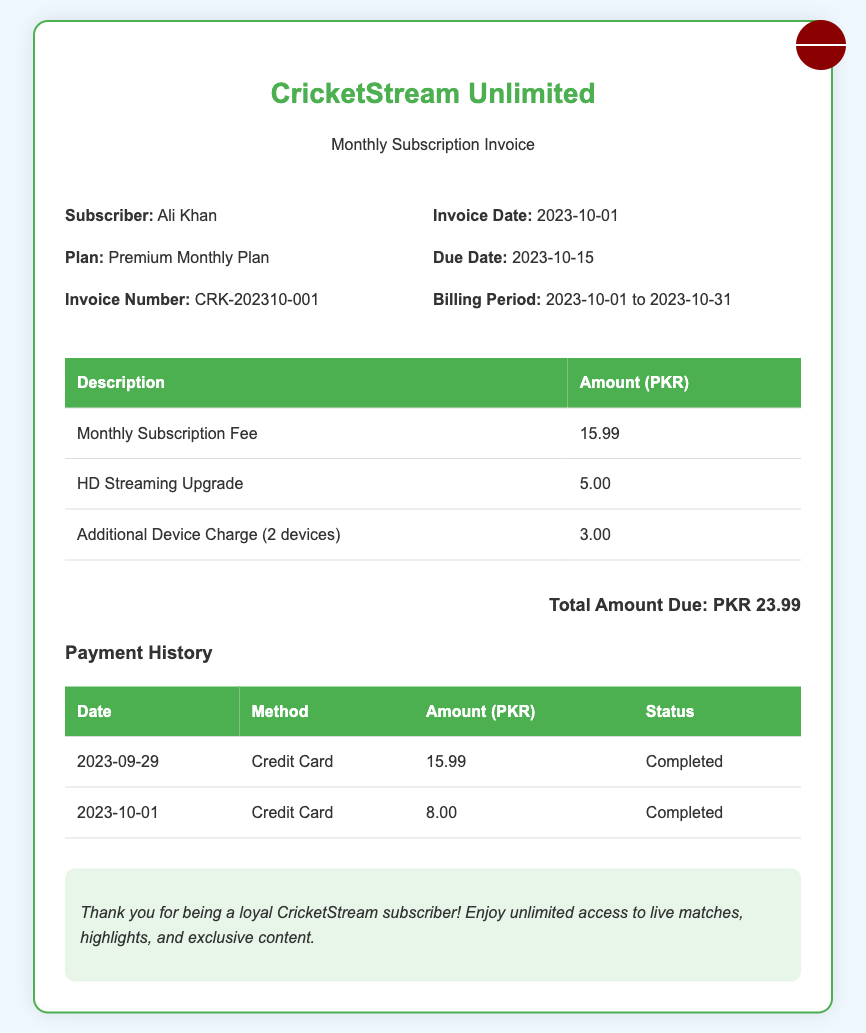What is the subscriber's name? The subscriber's name is mentioned in the document under the details section, which lists "Ali Khan."
Answer: Ali Khan What is the total amount due? The total amount due is listed at the bottom of the invoice as "Total Amount Due: PKR 23.99."
Answer: PKR 23.99 What is the invoice number? The invoice number is shown under the details section as "CRK-202310-001."
Answer: CRK-202310-001 What is the billing period? The billing period is specified in the details section, indicating the start and end dates as "2023-10-01 to 2023-10-31."
Answer: 2023-10-01 to 2023-10-31 How much is charged for the HD Streaming Upgrade? The charge for the HD Streaming Upgrade is detailed in the charges table, which states "5.00" PKR.
Answer: 5.00 What was the payment method on 2023-09-29? The payment method for that date is given in the payment history table, where it states "Credit Card."
Answer: Credit Card What is the status of the payment made on 2023-10-01? The status for this payment is noted in the payment history table, which shows "Completed."
Answer: Completed How many additional devices are charged? The invoice states there is a charge for "2 devices" under the additional device charge.
Answer: 2 devices What is the due date for the invoice? The due date is indicated in the details section as "2023-10-15."
Answer: 2023-10-15 